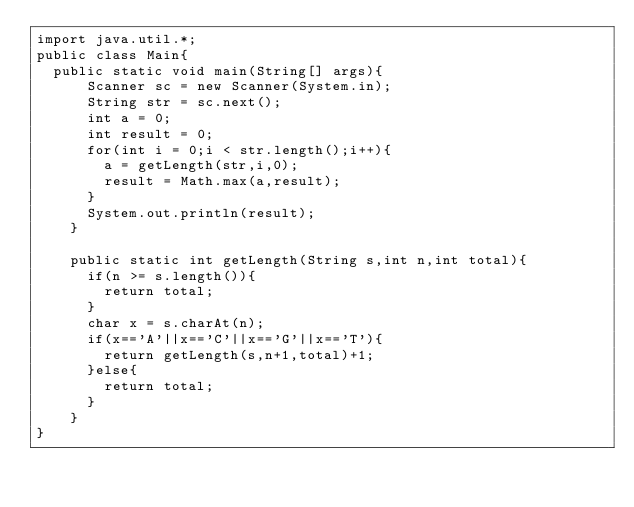Convert code to text. <code><loc_0><loc_0><loc_500><loc_500><_Java_>import java.util.*;
public class Main{
	public static void main(String[] args){
    	Scanner sc = new Scanner(System.in);
      String str = sc.next();
      int a = 0;
      int result = 0;
      for(int i = 0;i < str.length();i++){
      	a = getLength(str,i,0);
        result = Math.max(a,result);
      }
      System.out.println(result);
    }
  
  	public static int getLength(String s,int n,int total){
      if(n >= s.length()){
      	return total;
      }
      char x = s.charAt(n);
      if(x=='A'||x=='C'||x=='G'||x=='T'){
      	return getLength(s,n+1,total)+1;
      }else{
      	return total;
      }
    }
}</code> 